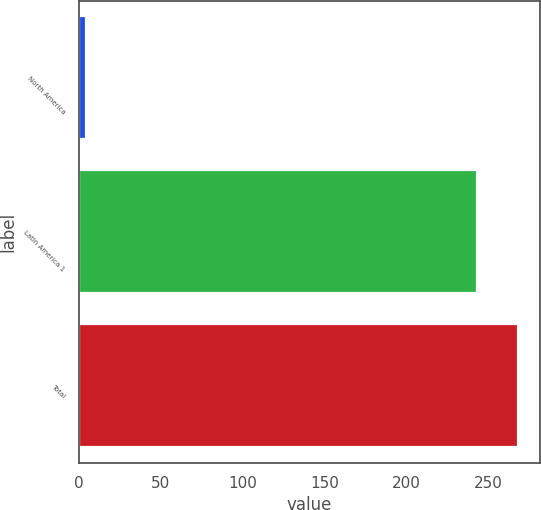<chart> <loc_0><loc_0><loc_500><loc_500><bar_chart><fcel>North America<fcel>Latin America 1<fcel>Total<nl><fcel>4<fcel>243<fcel>267.8<nl></chart> 